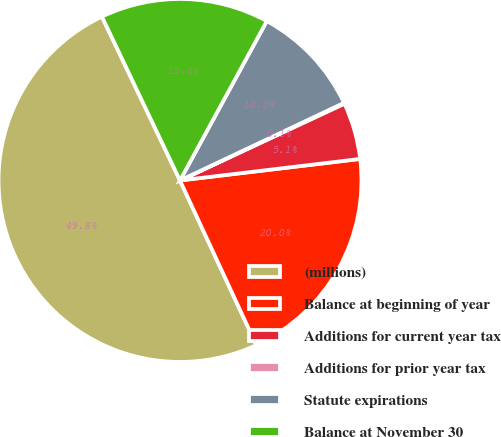<chart> <loc_0><loc_0><loc_500><loc_500><pie_chart><fcel>(millions)<fcel>Balance at beginning of year<fcel>Additions for current year tax<fcel>Additions for prior year tax<fcel>Statute expirations<fcel>Balance at November 30<nl><fcel>49.83%<fcel>19.98%<fcel>5.06%<fcel>0.08%<fcel>10.03%<fcel>15.01%<nl></chart> 